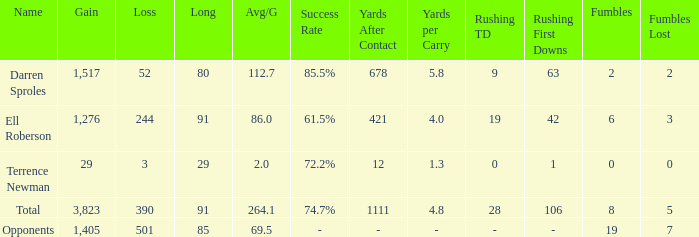When the player gained below 1,405 yards and lost over 390 yards, what's the sum of the long yards? None. 